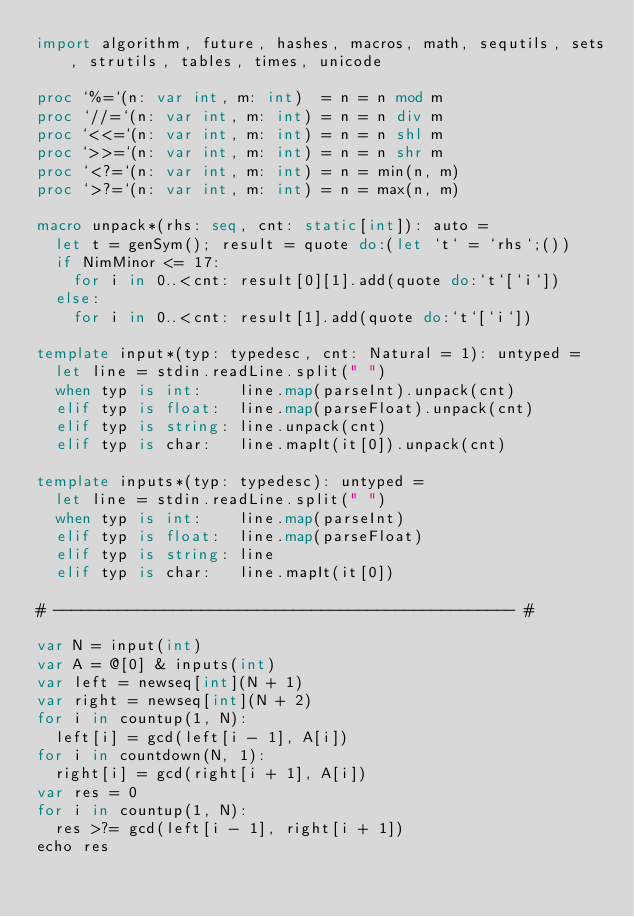Convert code to text. <code><loc_0><loc_0><loc_500><loc_500><_Nim_>import algorithm, future, hashes, macros, math, sequtils, sets, strutils, tables, times, unicode

proc `%=`(n: var int, m: int)  = n = n mod m
proc `//=`(n: var int, m: int) = n = n div m
proc `<<=`(n: var int, m: int) = n = n shl m
proc `>>=`(n: var int, m: int) = n = n shr m
proc `<?=`(n: var int, m: int) = n = min(n, m)
proc `>?=`(n: var int, m: int) = n = max(n, m)

macro unpack*(rhs: seq, cnt: static[int]): auto =
  let t = genSym(); result = quote do:(let `t` = `rhs`;())
  if NimMinor <= 17:
    for i in 0..<cnt: result[0][1].add(quote do:`t`[`i`])
  else:
    for i in 0..<cnt: result[1].add(quote do:`t`[`i`])

template input*(typ: typedesc, cnt: Natural = 1): untyped =
  let line = stdin.readLine.split(" ")
  when typ is int:    line.map(parseInt).unpack(cnt)
  elif typ is float:  line.map(parseFloat).unpack(cnt)
  elif typ is string: line.unpack(cnt)
  elif typ is char:   line.mapIt(it[0]).unpack(cnt)

template inputs*(typ: typedesc): untyped =
  let line = stdin.readLine.split(" ")
  when typ is int:    line.map(parseInt)
  elif typ is float:  line.map(parseFloat)
  elif typ is string: line
  elif typ is char:   line.mapIt(it[0])

# -------------------------------------------------- #

var N = input(int)
var A = @[0] & inputs(int)
var left = newseq[int](N + 1)
var right = newseq[int](N + 2)
for i in countup(1, N):
  left[i] = gcd(left[i - 1], A[i])
for i in countdown(N, 1):
  right[i] = gcd(right[i + 1], A[i])
var res = 0
for i in countup(1, N):
  res >?= gcd(left[i - 1], right[i + 1])
echo res</code> 